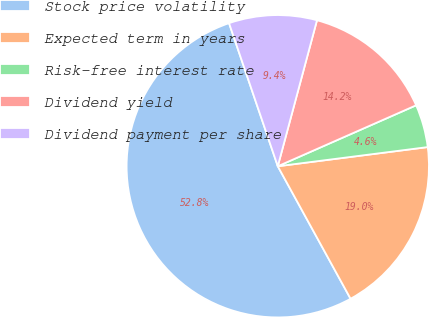Convert chart to OTSL. <chart><loc_0><loc_0><loc_500><loc_500><pie_chart><fcel>Stock price volatility<fcel>Expected term in years<fcel>Risk-free interest rate<fcel>Dividend yield<fcel>Dividend payment per share<nl><fcel>52.77%<fcel>19.03%<fcel>4.58%<fcel>14.22%<fcel>9.4%<nl></chart> 